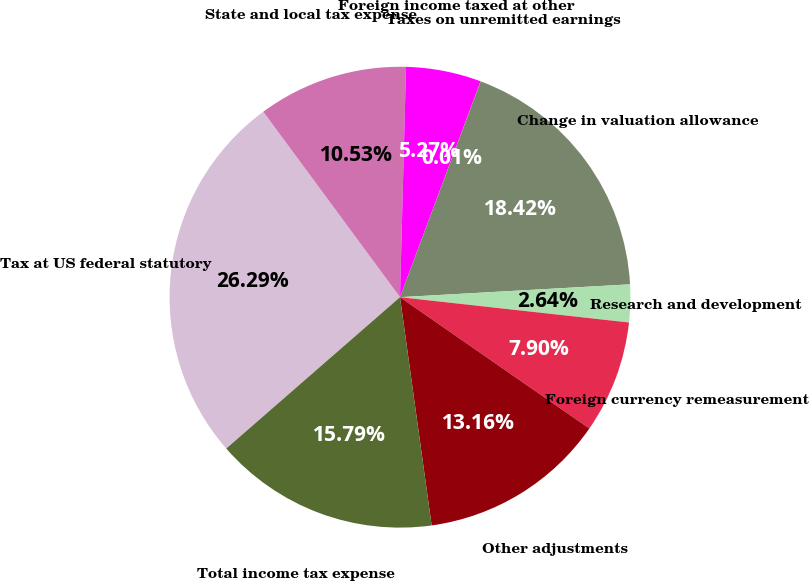Convert chart. <chart><loc_0><loc_0><loc_500><loc_500><pie_chart><fcel>Tax at US federal statutory<fcel>State and local tax expense<fcel>Foreign income taxed at other<fcel>Taxes on unremitted earnings<fcel>Change in valuation allowance<fcel>Research and development<fcel>Foreign currency remeasurement<fcel>Other adjustments<fcel>Total income tax expense<nl><fcel>26.3%<fcel>10.53%<fcel>5.27%<fcel>0.01%<fcel>18.42%<fcel>2.64%<fcel>7.9%<fcel>13.16%<fcel>15.79%<nl></chart> 